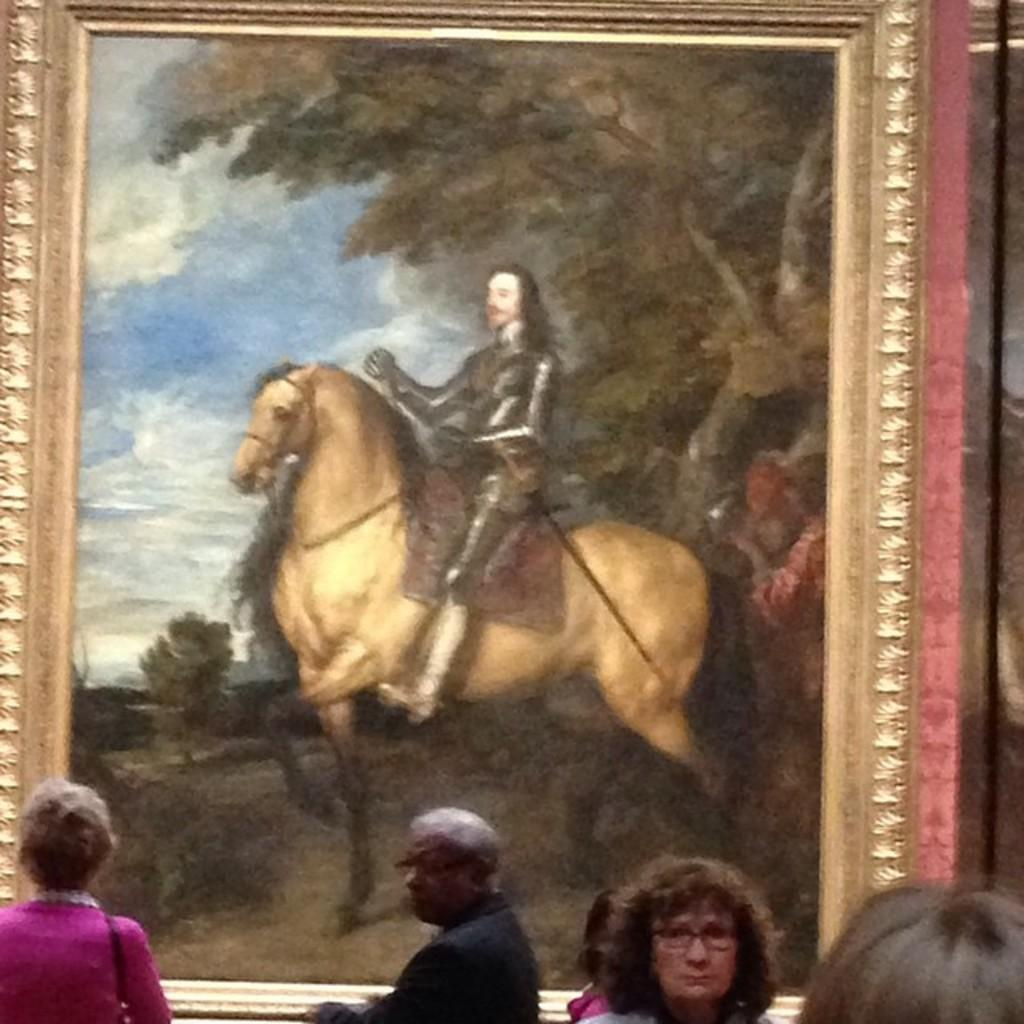What is the main subject of the image? There is a painting in the image. Can you describe the people in the image? There is a group of people in the image. What type of sock is the snake wearing in the image? There is no snake or sock present in the image. 